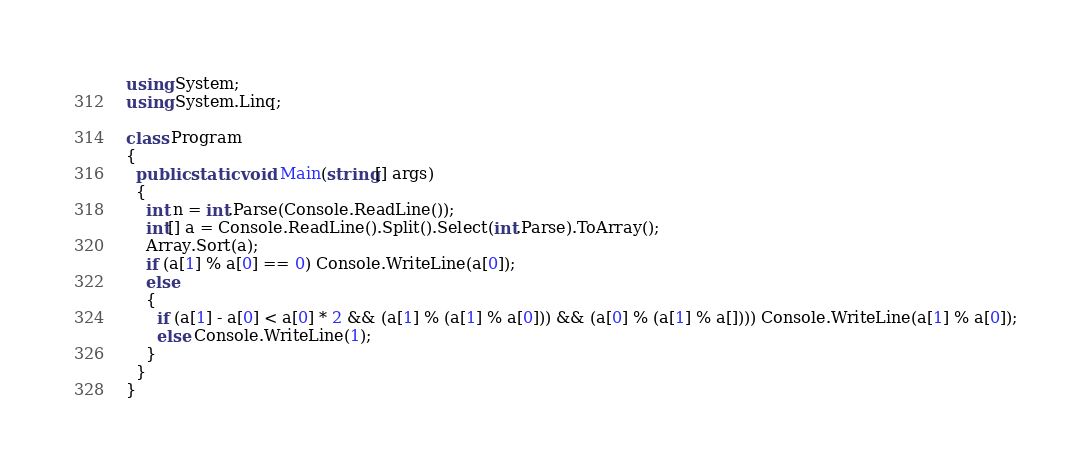<code> <loc_0><loc_0><loc_500><loc_500><_C#_>using System;
using System.Linq;

class Program
{
  public static void Main(string[] args)
  {
    int n = int.Parse(Console.ReadLine());
    int[] a = Console.ReadLine().Split().Select(int.Parse).ToArray();
    Array.Sort(a);
    if (a[1] % a[0] == 0) Console.WriteLine(a[0]);
    else
    {
      if (a[1] - a[0] < a[0] * 2 && (a[1] % (a[1] % a[0])) && (a[0] % (a[1] % a[]))) Console.WriteLine(a[1] % a[0]);
      else Console.WriteLine(1);
    }
  }
}
</code> 